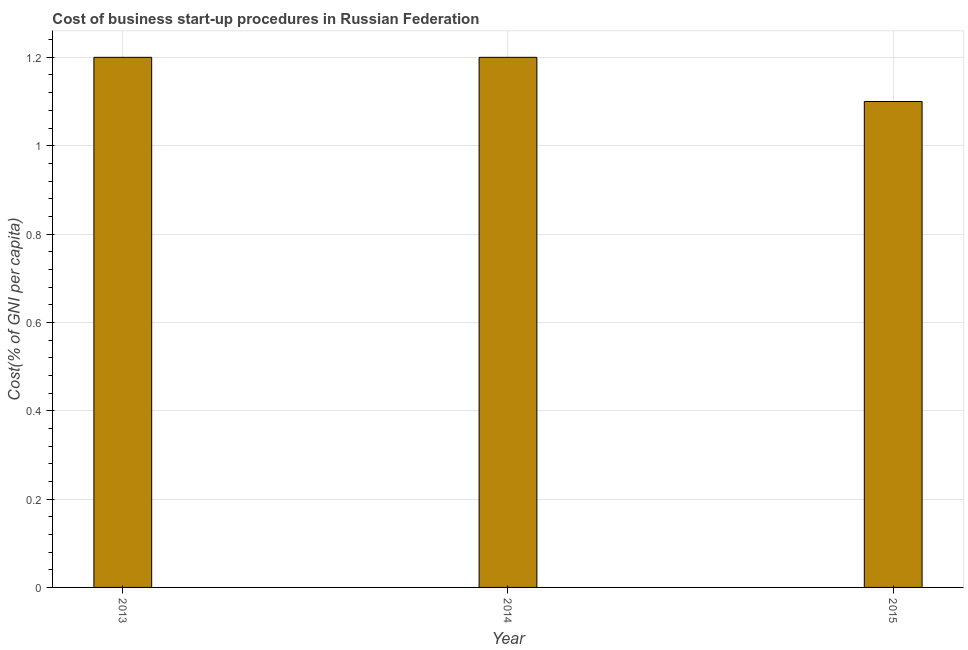Does the graph contain any zero values?
Provide a succinct answer. No. Does the graph contain grids?
Your answer should be compact. Yes. What is the title of the graph?
Your answer should be compact. Cost of business start-up procedures in Russian Federation. What is the label or title of the Y-axis?
Your response must be concise. Cost(% of GNI per capita). Across all years, what is the maximum cost of business startup procedures?
Ensure brevity in your answer.  1.2. In which year was the cost of business startup procedures maximum?
Make the answer very short. 2013. In which year was the cost of business startup procedures minimum?
Your answer should be very brief. 2015. What is the average cost of business startup procedures per year?
Give a very brief answer. 1.17. What is the median cost of business startup procedures?
Your answer should be very brief. 1.2. In how many years, is the cost of business startup procedures greater than 0.8 %?
Give a very brief answer. 3. Do a majority of the years between 2015 and 2013 (inclusive) have cost of business startup procedures greater than 0.6 %?
Provide a succinct answer. Yes. Is the cost of business startup procedures in 2013 less than that in 2015?
Your answer should be very brief. No. What is the difference between the highest and the second highest cost of business startup procedures?
Your answer should be very brief. 0. What is the difference between the highest and the lowest cost of business startup procedures?
Provide a short and direct response. 0.1. In how many years, is the cost of business startup procedures greater than the average cost of business startup procedures taken over all years?
Keep it short and to the point. 2. How many bars are there?
Offer a very short reply. 3. What is the difference between two consecutive major ticks on the Y-axis?
Your response must be concise. 0.2. What is the Cost(% of GNI per capita) of 2015?
Make the answer very short. 1.1. What is the ratio of the Cost(% of GNI per capita) in 2013 to that in 2015?
Provide a succinct answer. 1.09. What is the ratio of the Cost(% of GNI per capita) in 2014 to that in 2015?
Make the answer very short. 1.09. 